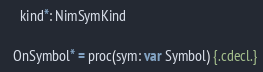Convert code to text. <code><loc_0><loc_0><loc_500><loc_500><_Nim_>    kind*: NimSymKind

  OnSymbol* = proc(sym: var Symbol) {.cdecl.}</code> 